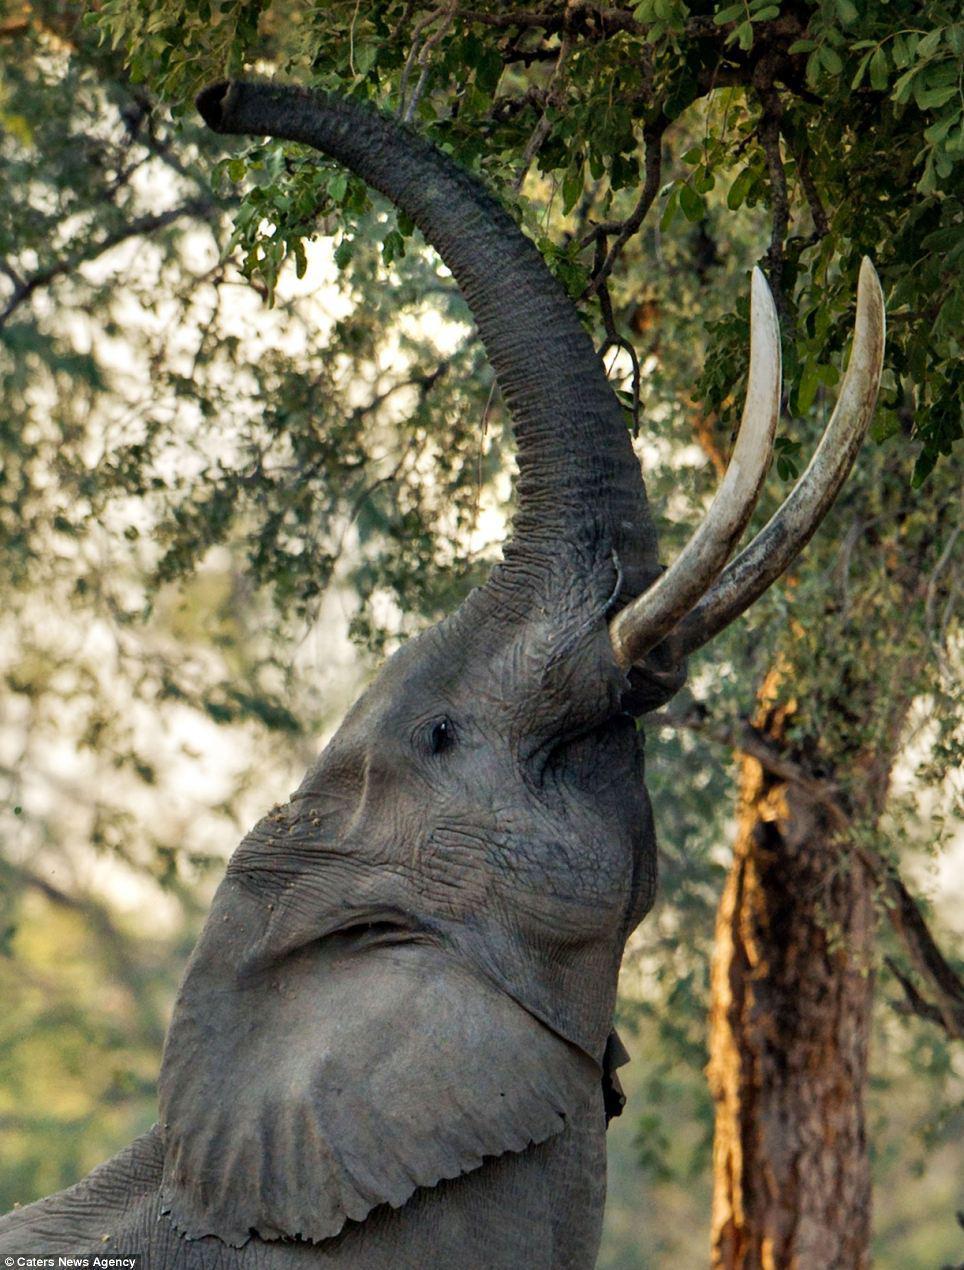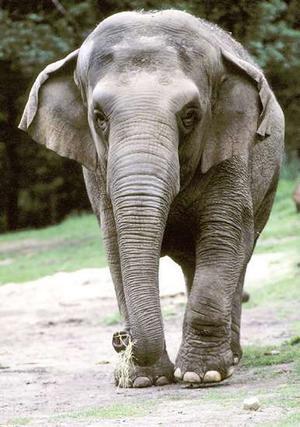The first image is the image on the left, the second image is the image on the right. For the images displayed, is the sentence "One of the elephants is facing upwards." factually correct? Answer yes or no. Yes. 